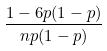Convert formula to latex. <formula><loc_0><loc_0><loc_500><loc_500>\frac { 1 - 6 p ( 1 - p ) } { n p ( 1 - p ) }</formula> 